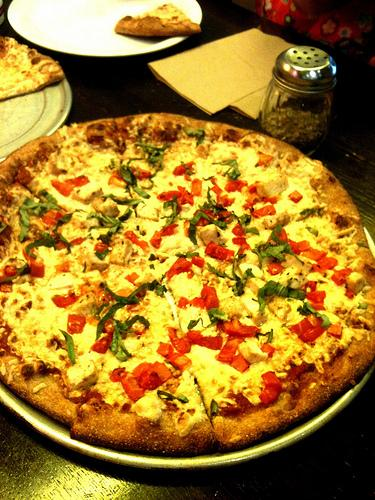What types of materials are the objects in the image made of? Wood for the table, metal for the pizza pan, glass for the salt shaker, and paper for the napkins are some of the materials the objects are made of. Can you describe the color and appearance of the pizza crust? The pizza crust is brown in color, giving it a well-baked appearance. Please provide a detailed description of the pizza in the image. The pizza is large, cut into triangular pieces, and has many toppings such as chicken, green and red vegetables, and tomatoes. It is placed on a gray metal pizza pan resting on a brown wooden table. What kind of seasoning is present on the table? Please describe the container. A shaker of oregano in a glass container is present on the table. List all the pizza toppings you can identify in the image. Chicken, red tomatoes, and green vegetables are the identifiable toppings on the pizza. Describe the characteristics of the table the pizza is placed on. The table is made of brown wood and has a light reflection visible on its surface. What type of food is the supporting object to the pizza and how are they served? A single slice of pizza is served on a silver pan and another bite of pizza is placed on a white plate, both being supporting objects to the whole pizza. Estimate the number of whole pizzas visible in the image. There are at least six instances of whole pizzas visible in the image. Express the sentiment or atmosphere portrayed in the image. The image depicts a comforting and warm atmosphere, with a visually appealing pizza served on a wooden table, surrounded by various other objects. Mention some objects that can be found on the table alongside the pizza. A shaker of oregano, a jar of pizza seasoning, a white plate with a bite of pizza, a silver pan with a single slice of pizza, and a couple of brown paper napkins are on the table. Can you spot the dog sitting beside the table and staring at the pizza? You'll notice how its brown fur matches the color of the wooden table. There is no mention of a dog in the list of objects, so this instruction points to a non-existent object. It also uses an interrogative sentence, requiring the reader to search for the dog, and a declarative sentence describing the supposed dog. Is the pizza delivery person visible in the reflection on the metallic pan? They must be waiting for a tip, dressed in their uniform. There is no mention of a pizza delivery person in the list of objects, so this instruction is misleading. It uses an interrogative sentence to urge readers to try to find the person and a declarative sentence to further describe the non-existent object. Did you notice the half-empty bottle of soda placed right next to the plate with the pizza slice? Its label has vibrant colors, making it stand out. There is no mention of a bottle of soda in the list of objects, so this instruction is misleading. It uses an interrogative sentence to provoke curiosity and a declarative sentence to further describe the non-existent object. Notice the quirky poster on the wall behind the table, featuring an amusing pizza-related joke. It contributes to the cheerful ambience. There is no mention of a poster in the list of objects provided, so this instruction refers to a non-existent object. The use of declarative sentences might make viewers question whether they're looking at the correct image or searching for something that isn't there. Observe the small plant in the corner of the image, adding a touch of greenery to the scene. The leaves have a unique shape that captures attention. No plant is mentioned in the image details, so this instruction is misleading. It uses declarative sentences to describe the non-existent object, which could make readers question if they're missing something in the image. Take a look at the red-checkered tablecloth covering the table. It creates a classic Italian pizzeria atmosphere. There is no mention of a tablecloth in the image details, so this instruction points to a non-existent object. It uses declarative sentences to describe the supposed tablecloth, which could make readers question their perception of the image. 